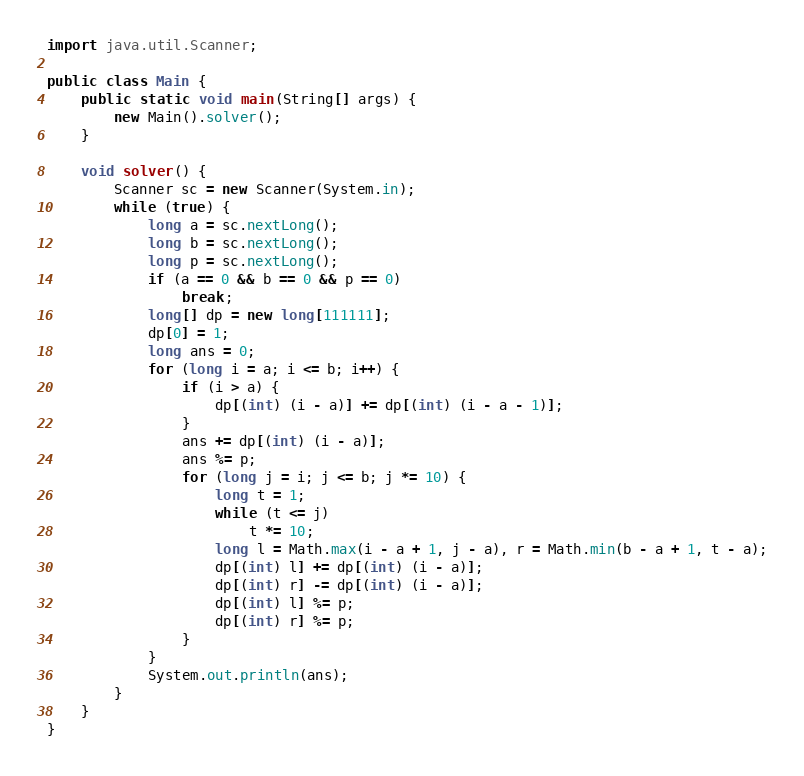Convert code to text. <code><loc_0><loc_0><loc_500><loc_500><_Java_>import java.util.Scanner;

public class Main {
	public static void main(String[] args) {
		new Main().solver();
	}

	void solver() {
		Scanner sc = new Scanner(System.in);
		while (true) {
			long a = sc.nextLong();
			long b = sc.nextLong();
			long p = sc.nextLong();
			if (a == 0 && b == 0 && p == 0)
				break;
			long[] dp = new long[111111];
			dp[0] = 1;
			long ans = 0;
			for (long i = a; i <= b; i++) {
				if (i > a) {
					dp[(int) (i - a)] += dp[(int) (i - a - 1)];
				}
				ans += dp[(int) (i - a)];
				ans %= p;
				for (long j = i; j <= b; j *= 10) {
					long t = 1;
					while (t <= j)
						t *= 10;
					long l = Math.max(i - a + 1, j - a), r = Math.min(b - a + 1, t - a);
					dp[(int) l] += dp[(int) (i - a)];
					dp[(int) r] -= dp[(int) (i - a)];
					dp[(int) l] %= p;
					dp[(int) r] %= p;
				}
			}
			System.out.println(ans);
		}
	}
}</code> 